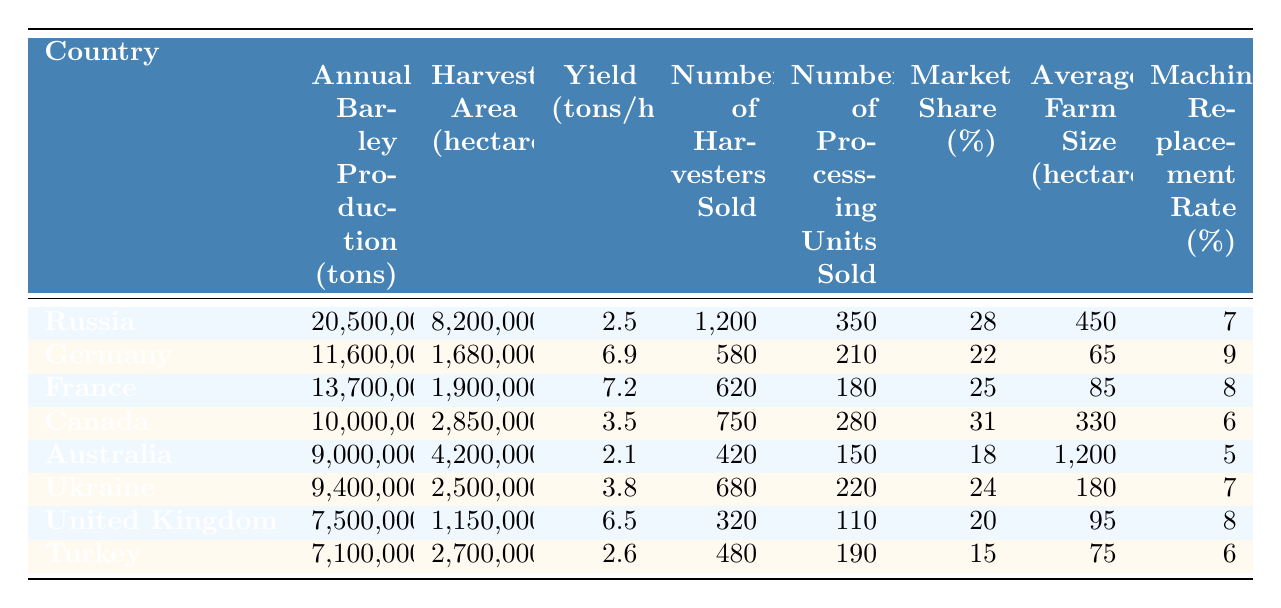What country has the highest annual barley production? By examining the "Annual Barley Production (tons)" column, we can see that Russia has the largest value at 20,500,000 tons, compared to other countries in the list.
Answer: Russia How many harvesters were sold in Canada? Referring directly to the "Number of Harvesters Sold" column, Canada shows a figure of 750 harvesters sold.
Answer: 750 Which country has the highest yield per hectare? Looking at the "Yield (tons/hectare)" column, France has the highest yield with a value of 7.2 tons per hectare.
Answer: France What is the total number of processing units sold across all countries? To find the total, we add all the values in the "Number of Processing Units Sold" column: 350 + 210 + 180 + 280 + 150 + 220 + 110 + 190 = 1,690.
Answer: 1,690 Which country has the largest average farm size? In the "Average Farm Size (hectares)" column, Australia shows the largest size at 1200 hectares compared to all others.
Answer: Australia Is the market share of Turkey greater than 20%? By referencing the "Market Share (%)" column, Turkey has a market share of 15%, which is less than 20%. Therefore, the answer is no.
Answer: No What is the difference in annual barley production between Germany and the United Kingdom? The annual barley production for Germany is 11,600,000 tons, while the United Kingdom is 7,500,000 tons. The difference is calculated as 11,600,000 - 7,500,000 = 4,100,000 tons.
Answer: 4,100,000 tons What percentage of the harvested area does Canada use compared to Russia? The harvested area for Canada is 2,850,000 hectares and for Russia it is 8,200,000 hectares. To find the percentage of Canada's area relative to Russia's, we calculate (2,850,000 / 8,200,000) * 100 ≈ 34.8%.
Answer: 34.8% Which country has the lowest machinery replacement rate? By checking the "Machinery Replacement Rate (%)" column, we find that Australia has the lowest rate at 5%.
Answer: Australia If we average the yields of all countries, what would that value be? The yields for each country are as follows: 2.5, 6.9, 7.2, 3.5, 2.1, 3.8, 6.5, 2.6. The sum is 35.6 and divides by 8 (the number of entries) gives an average yield of 4.45 tons per hectare.
Answer: 4.45 tons/hectare 